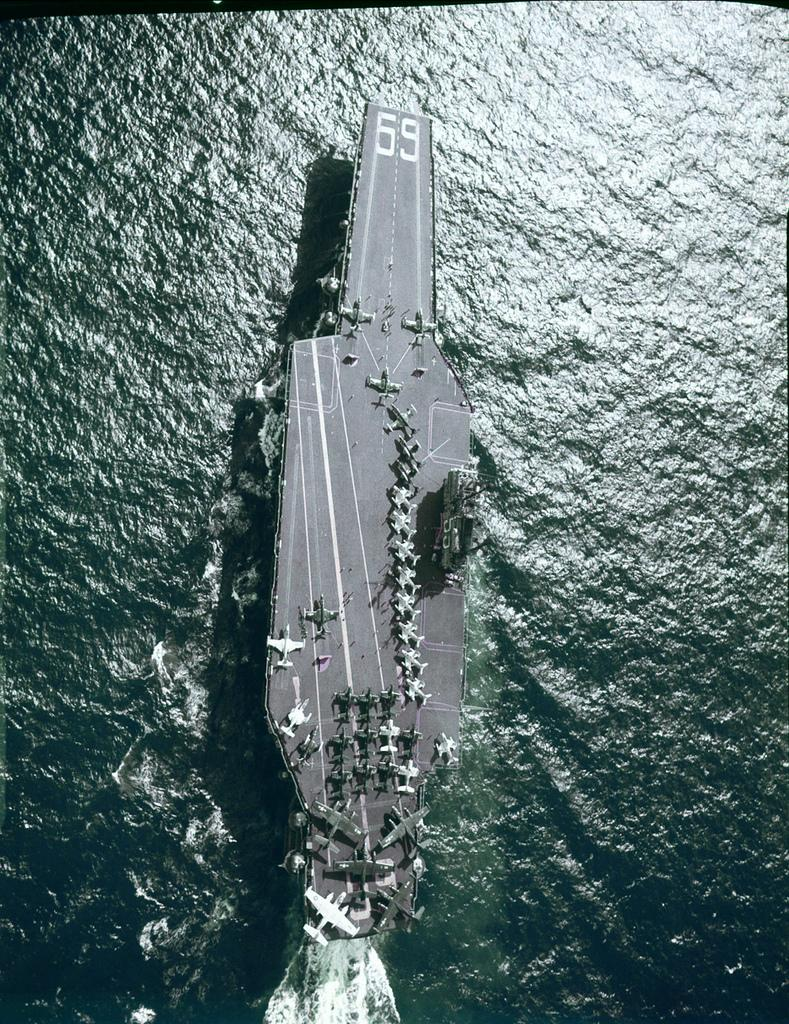What is the main subject of the image? The main subject of the image is a boat. Where is the boat located in the image? The boat is on the water. What other vehicles can be seen on the boat? There are aircrafts on the boat. How is the distribution of the nose in the image? There is no nose present in the image, as it features a boat on the water with aircrafts on it. What is the mind of the boat in the image? Boats do not have minds, as they are inanimate objects. 